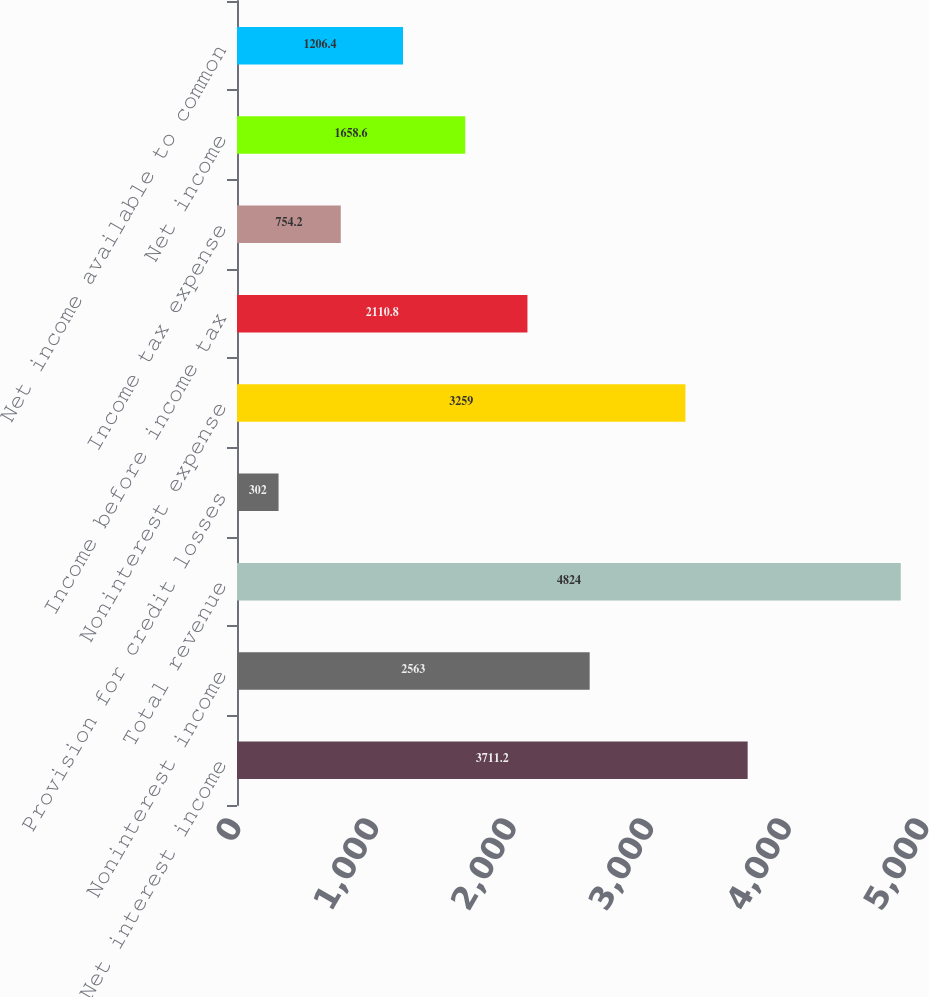Convert chart. <chart><loc_0><loc_0><loc_500><loc_500><bar_chart><fcel>Net interest income<fcel>Noninterest income<fcel>Total revenue<fcel>Provision for credit losses<fcel>Noninterest expense<fcel>Income before income tax<fcel>Income tax expense<fcel>Net income<fcel>Net income available to common<nl><fcel>3711.2<fcel>2563<fcel>4824<fcel>302<fcel>3259<fcel>2110.8<fcel>754.2<fcel>1658.6<fcel>1206.4<nl></chart> 